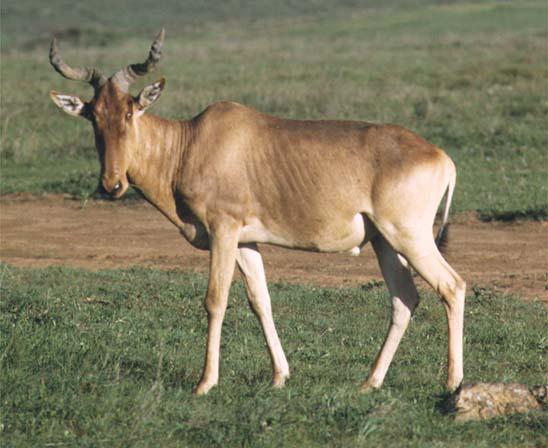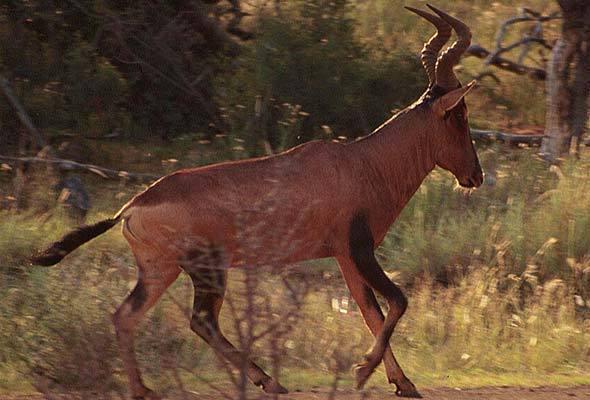The first image is the image on the left, the second image is the image on the right. Evaluate the accuracy of this statement regarding the images: "The right hand image contains an animal facing left.". Is it true? Answer yes or no. No. 